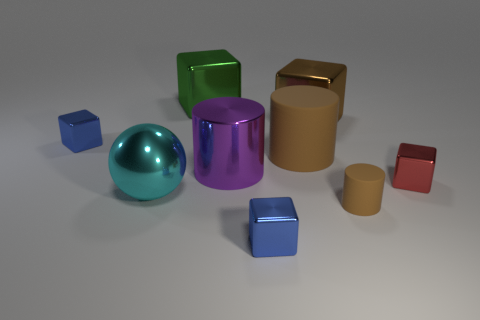Subtract all tiny cubes. How many cubes are left? 2 Subtract all red cubes. How many cubes are left? 4 Subtract all cylinders. How many objects are left? 6 Subtract 1 cylinders. How many cylinders are left? 2 Subtract all large cyan metal objects. Subtract all big cyan shiny spheres. How many objects are left? 7 Add 6 big purple cylinders. How many big purple cylinders are left? 7 Add 3 small yellow matte balls. How many small yellow matte balls exist? 3 Subtract 0 red cylinders. How many objects are left? 9 Subtract all gray blocks. Subtract all blue cylinders. How many blocks are left? 5 Subtract all purple spheres. How many purple cylinders are left? 1 